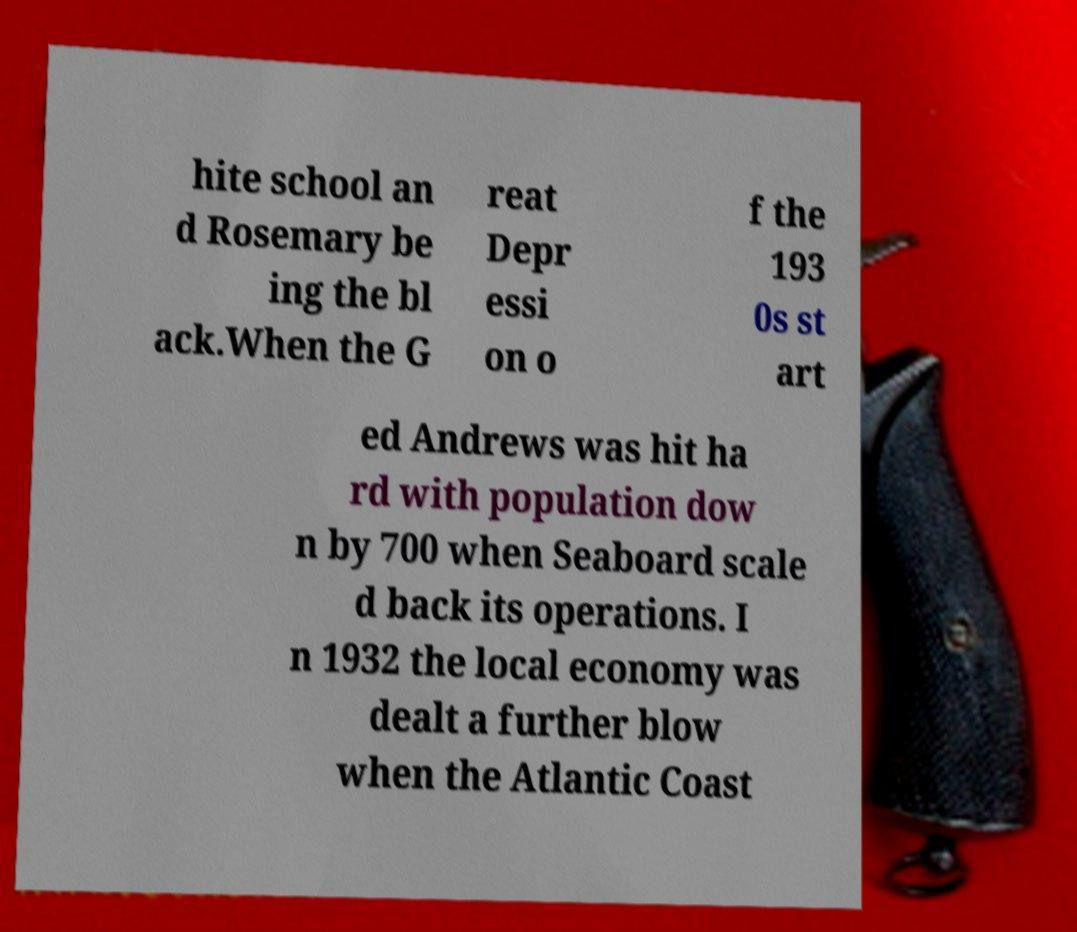For documentation purposes, I need the text within this image transcribed. Could you provide that? hite school an d Rosemary be ing the bl ack.When the G reat Depr essi on o f the 193 0s st art ed Andrews was hit ha rd with population dow n by 700 when Seaboard scale d back its operations. I n 1932 the local economy was dealt a further blow when the Atlantic Coast 